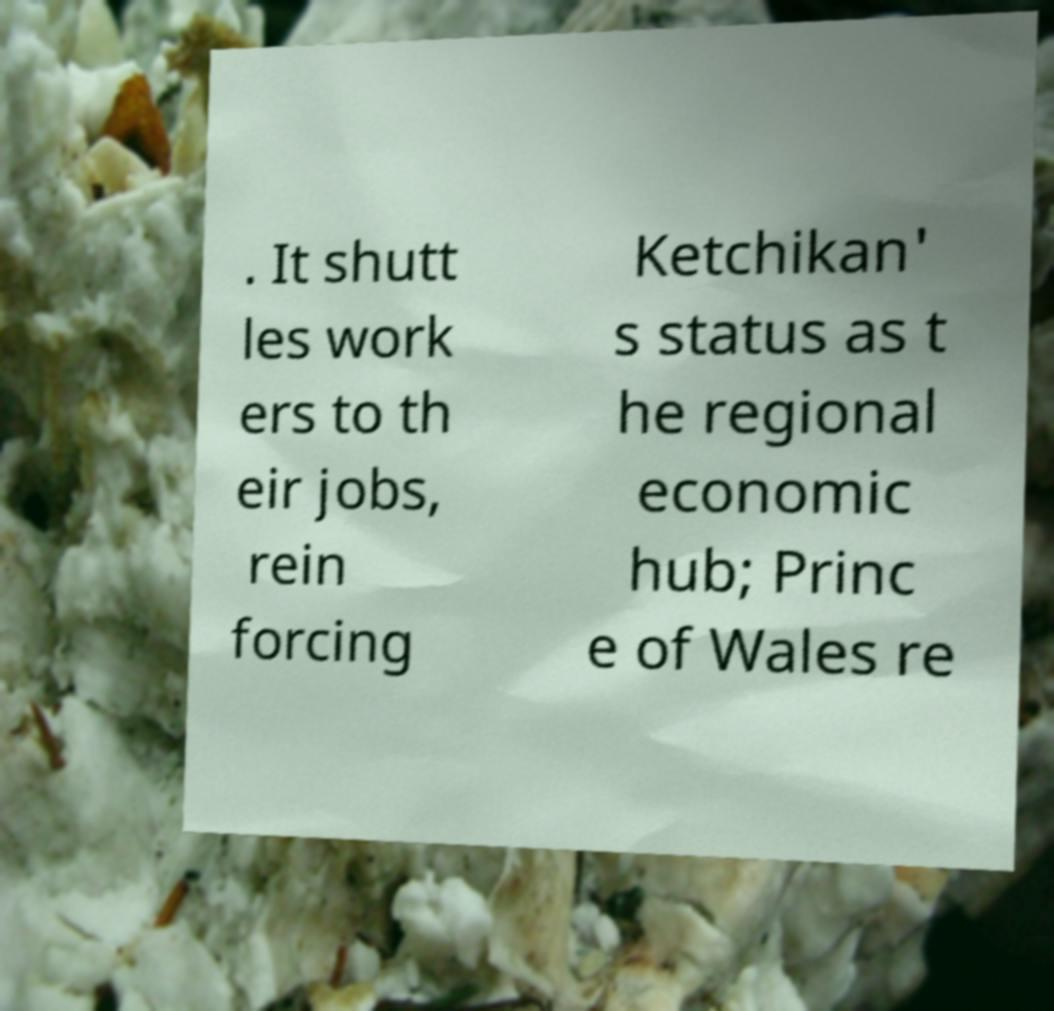Could you assist in decoding the text presented in this image and type it out clearly? . It shutt les work ers to th eir jobs, rein forcing Ketchikan' s status as t he regional economic hub; Princ e of Wales re 